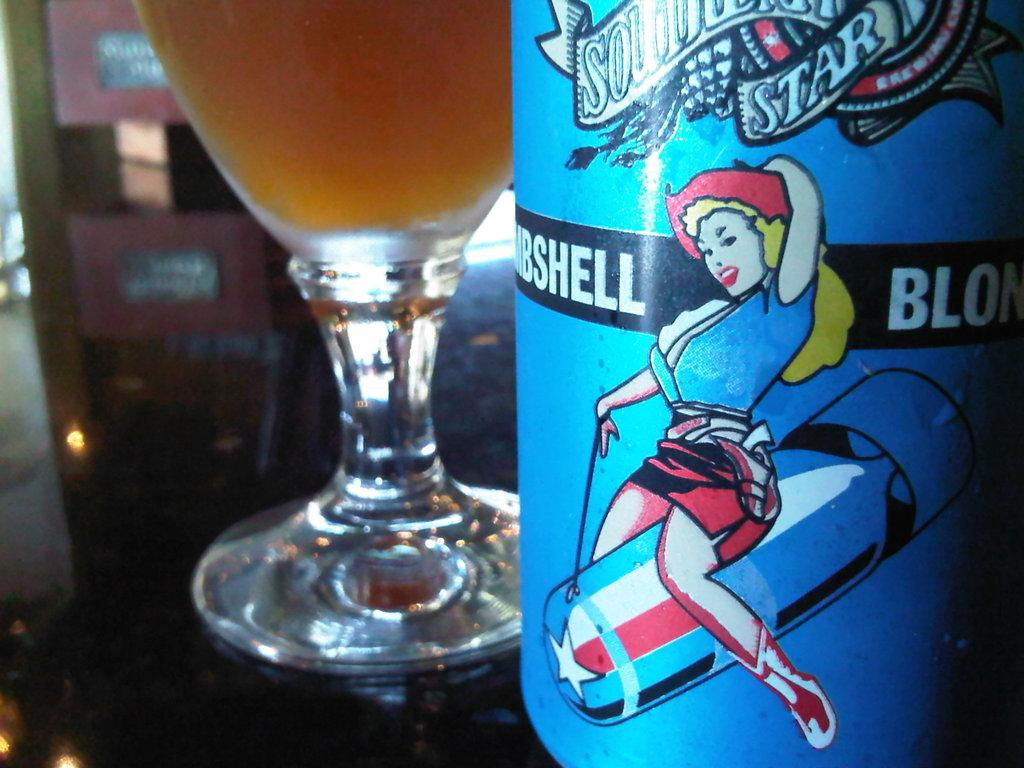<image>
Relay a brief, clear account of the picture shown. A glass of beer sits by a bottle with a drawing of a woman riding a bomb and the words Bombshell Blonde on it. 